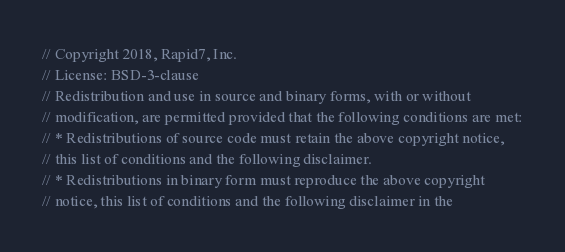Convert code to text. <code><loc_0><loc_0><loc_500><loc_500><_Go_>// Copyright 2018, Rapid7, Inc.
// License: BSD-3-clause
// Redistribution and use in source and binary forms, with or without
// modification, are permitted provided that the following conditions are met:
// * Redistributions of source code must retain the above copyright notice,
// this list of conditions and the following disclaimer.
// * Redistributions in binary form must reproduce the above copyright
// notice, this list of conditions and the following disclaimer in the</code> 